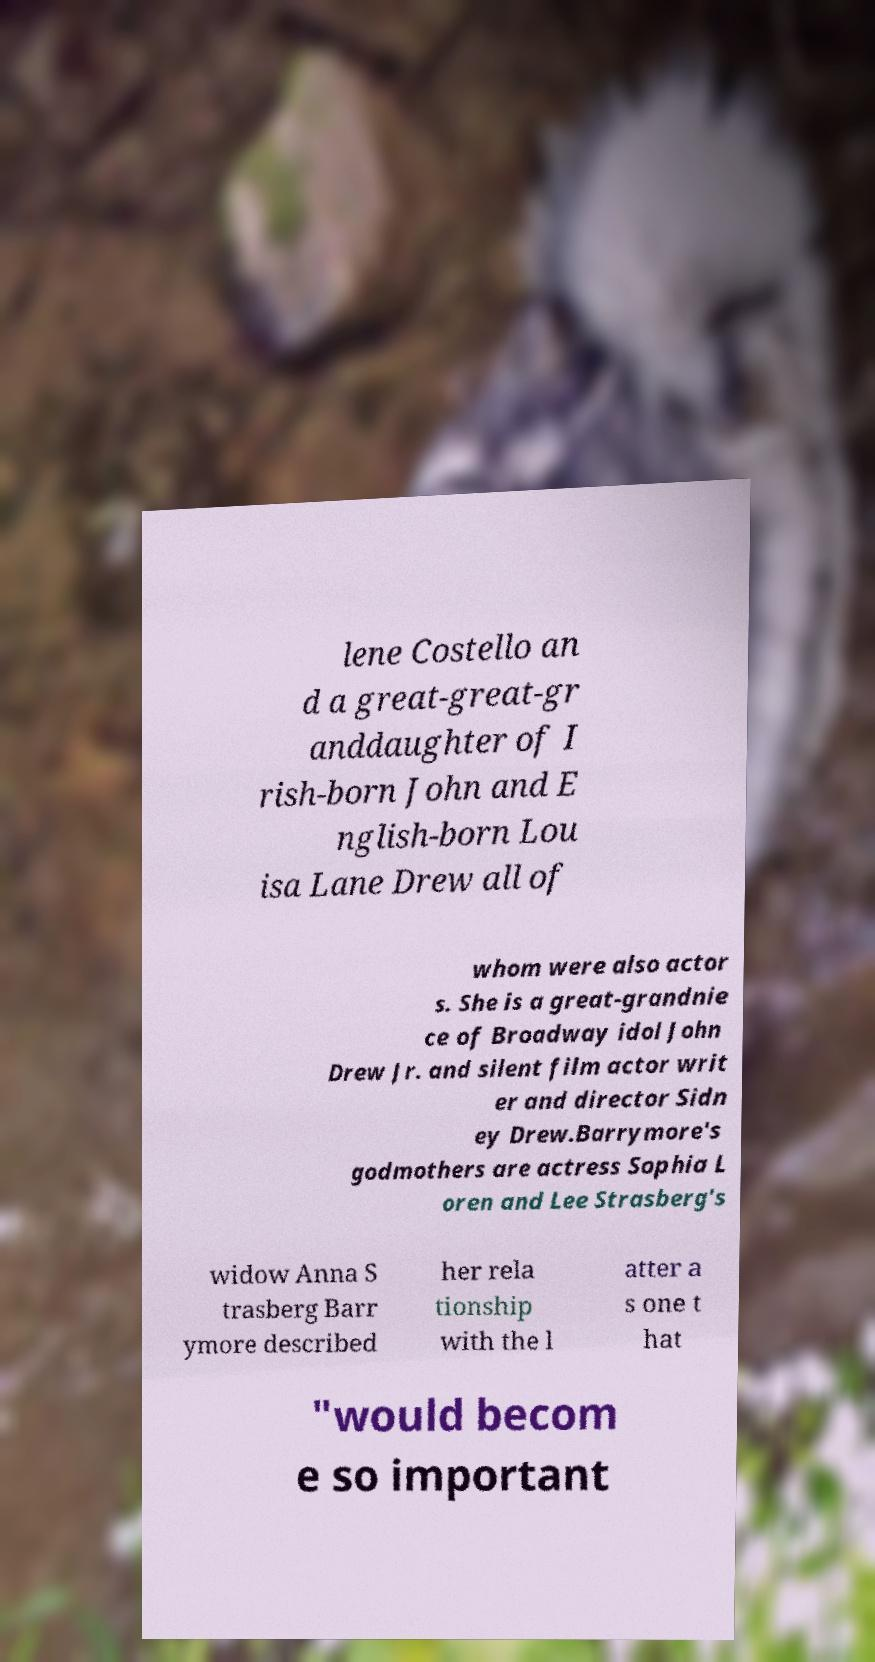Could you assist in decoding the text presented in this image and type it out clearly? lene Costello an d a great-great-gr anddaughter of I rish-born John and E nglish-born Lou isa Lane Drew all of whom were also actor s. She is a great-grandnie ce of Broadway idol John Drew Jr. and silent film actor writ er and director Sidn ey Drew.Barrymore's godmothers are actress Sophia L oren and Lee Strasberg's widow Anna S trasberg Barr ymore described her rela tionship with the l atter a s one t hat "would becom e so important 